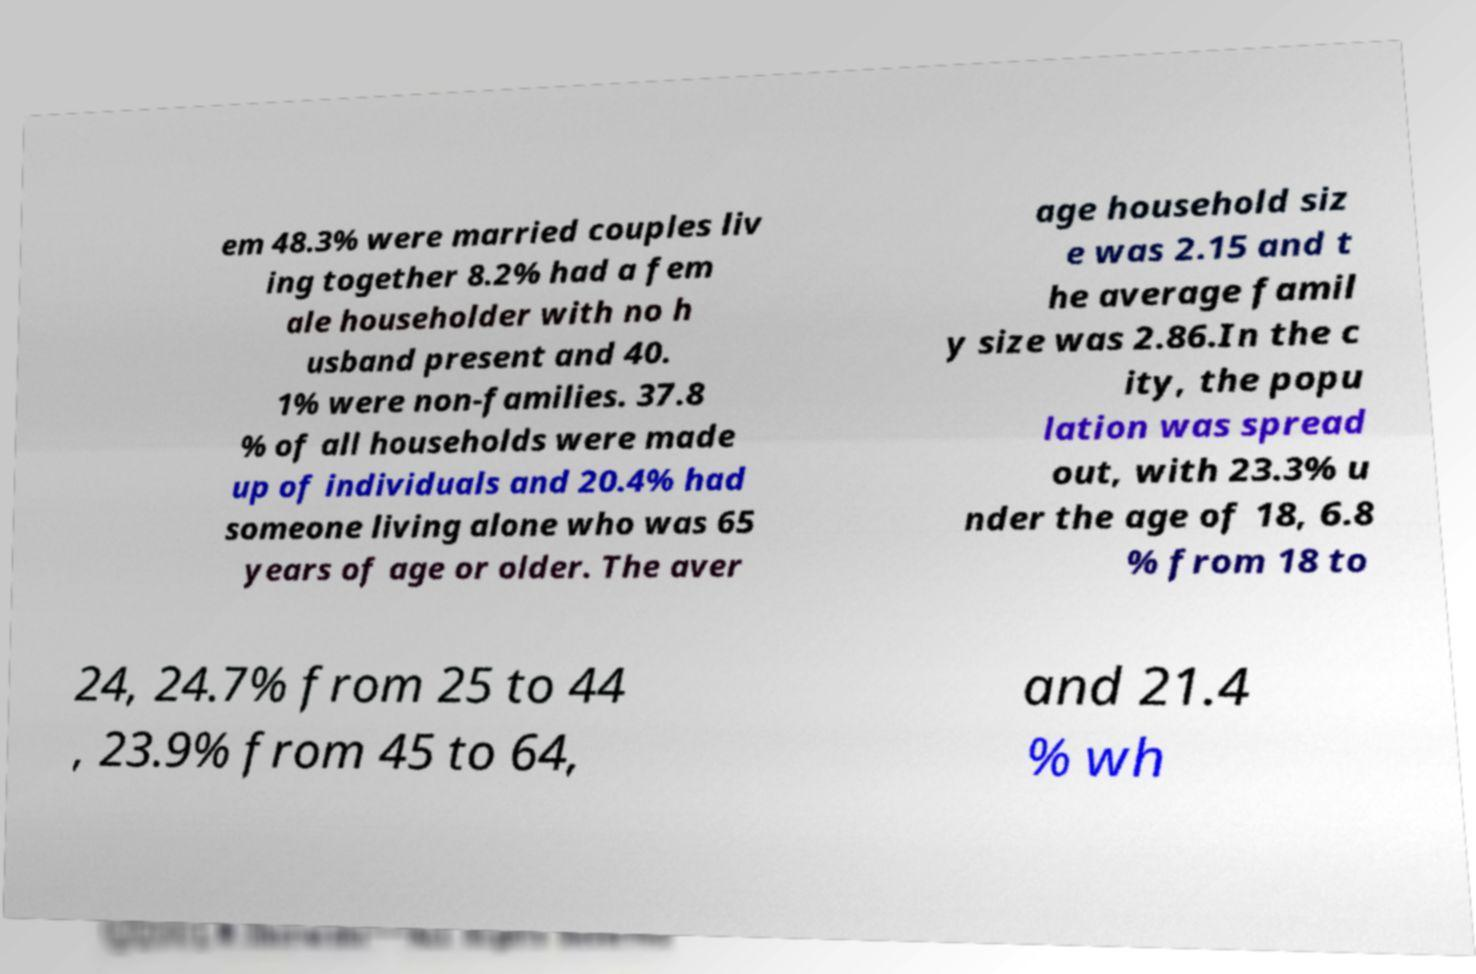Can you read and provide the text displayed in the image?This photo seems to have some interesting text. Can you extract and type it out for me? em 48.3% were married couples liv ing together 8.2% had a fem ale householder with no h usband present and 40. 1% were non-families. 37.8 % of all households were made up of individuals and 20.4% had someone living alone who was 65 years of age or older. The aver age household siz e was 2.15 and t he average famil y size was 2.86.In the c ity, the popu lation was spread out, with 23.3% u nder the age of 18, 6.8 % from 18 to 24, 24.7% from 25 to 44 , 23.9% from 45 to 64, and 21.4 % wh 